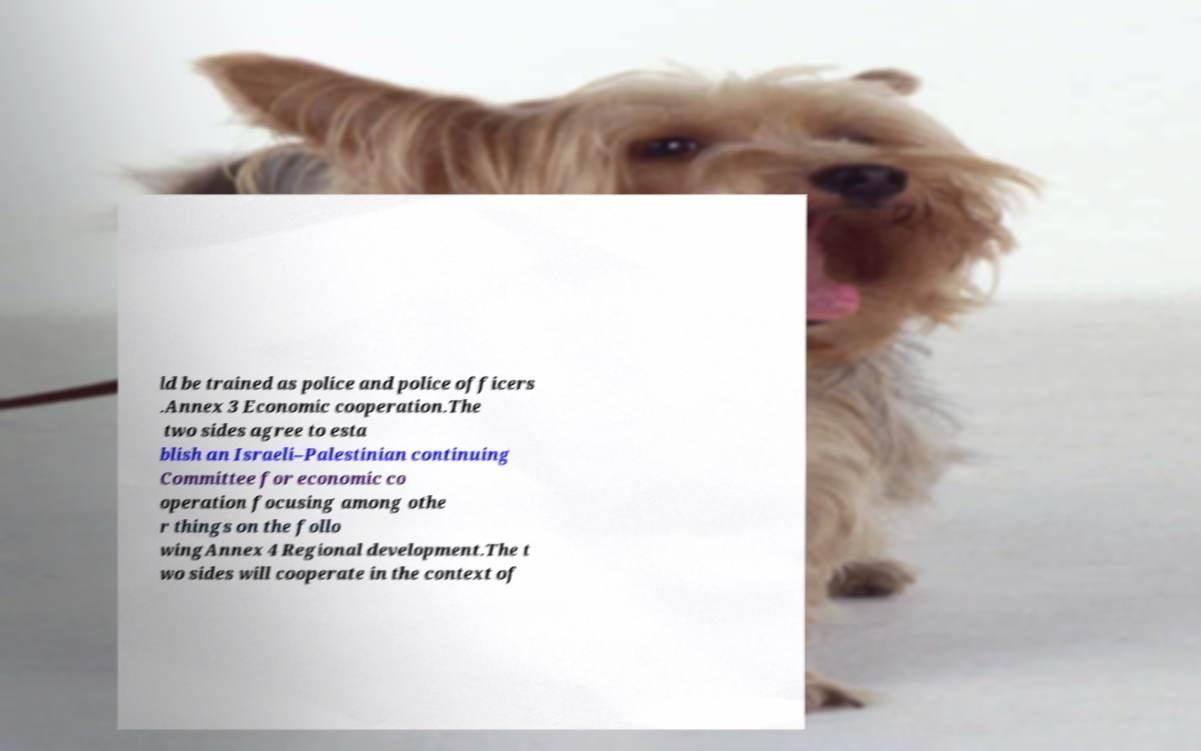I need the written content from this picture converted into text. Can you do that? ld be trained as police and police officers .Annex 3 Economic cooperation.The two sides agree to esta blish an Israeli–Palestinian continuing Committee for economic co operation focusing among othe r things on the follo wingAnnex 4 Regional development.The t wo sides will cooperate in the context of 